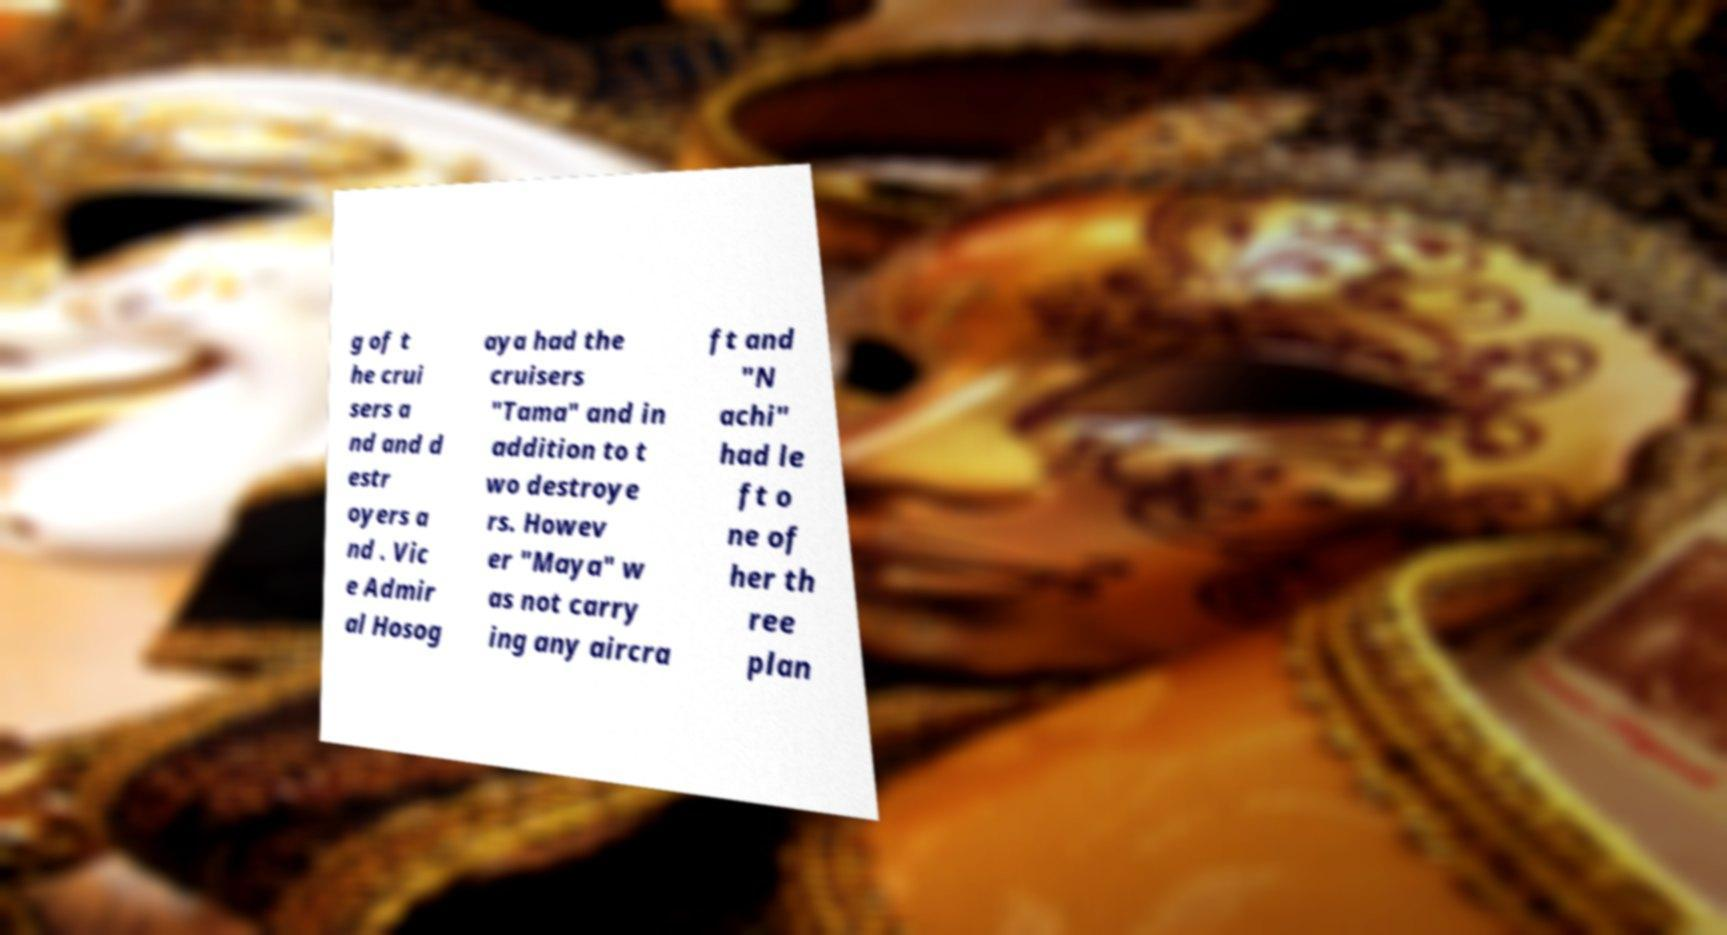Can you accurately transcribe the text from the provided image for me? g of t he crui sers a nd and d estr oyers a nd . Vic e Admir al Hosog aya had the cruisers "Tama" and in addition to t wo destroye rs. Howev er "Maya" w as not carry ing any aircra ft and "N achi" had le ft o ne of her th ree plan 